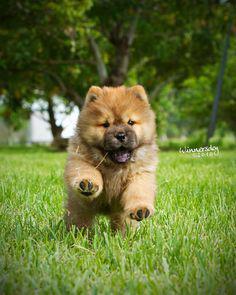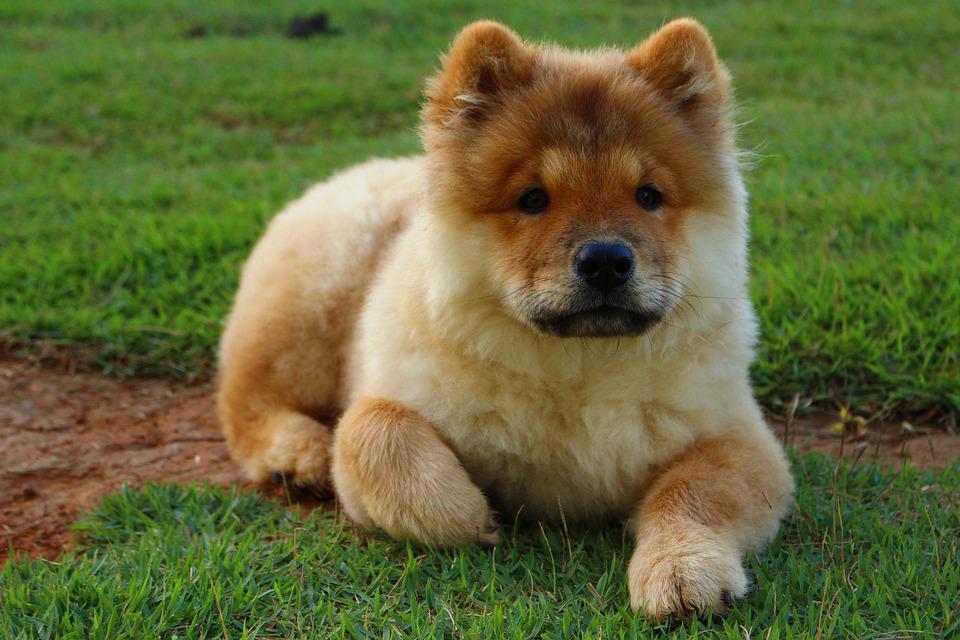The first image is the image on the left, the second image is the image on the right. Given the left and right images, does the statement "a puppy is leaping in the grass" hold true? Answer yes or no. Yes. The first image is the image on the left, the second image is the image on the right. For the images displayed, is the sentence "One of the images shows a fluffy puppy running over grass toward the camera." factually correct? Answer yes or no. Yes. 